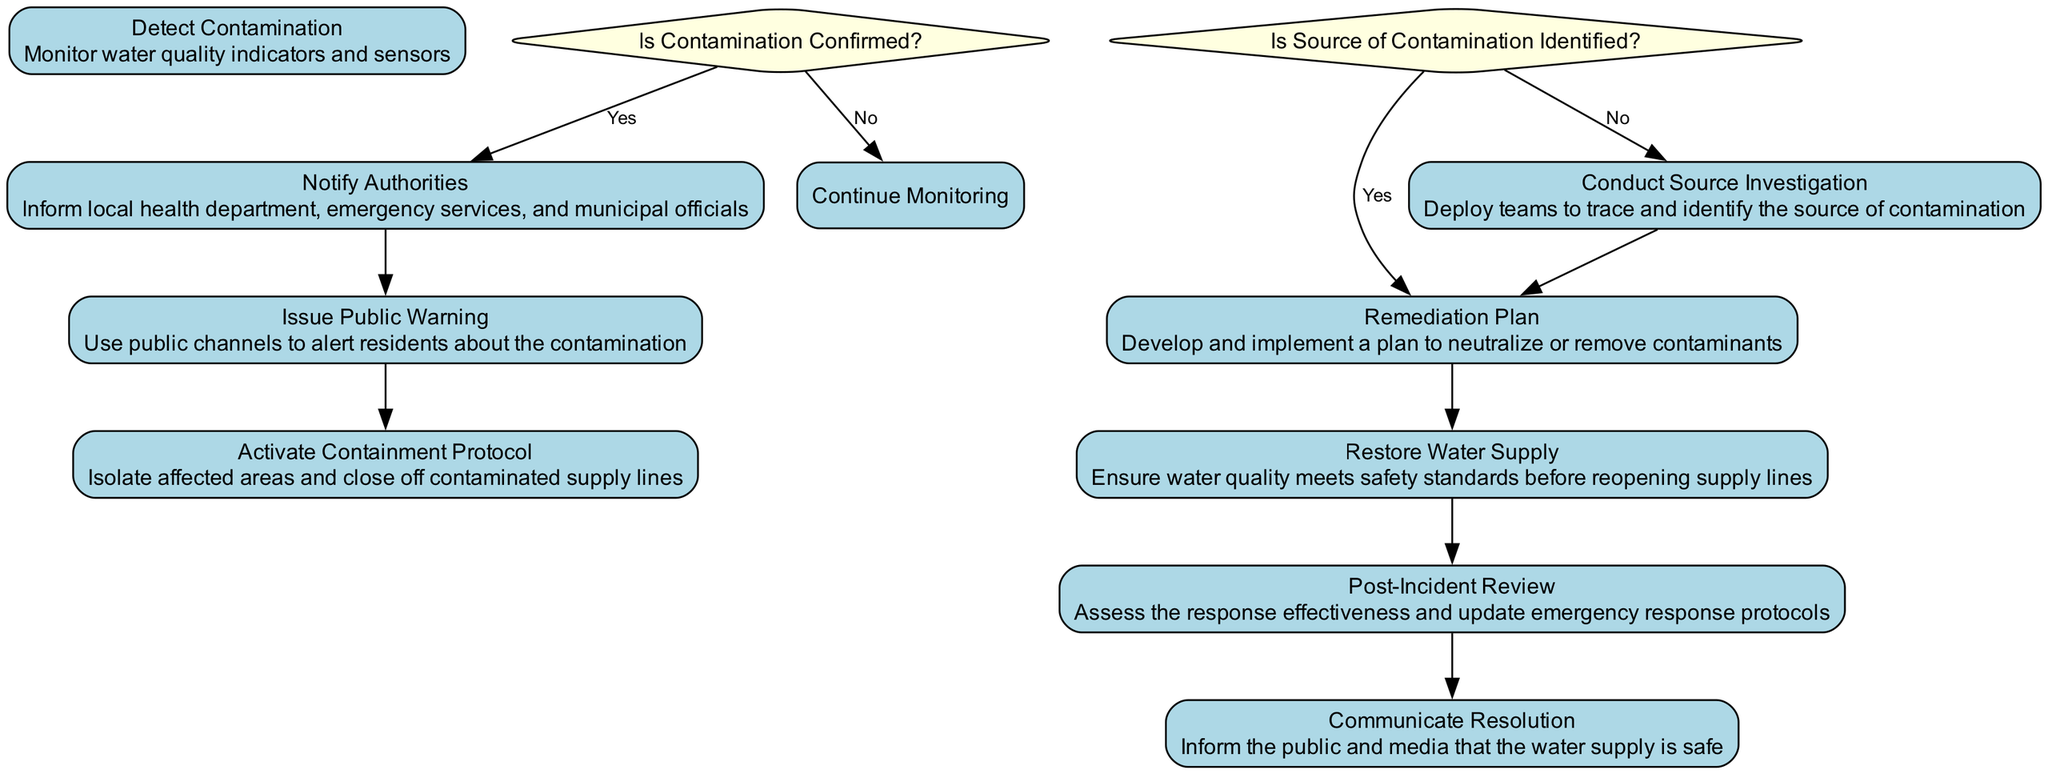What's the first activity in the diagram? The first activity listed in the diagram is "Detect Contamination", which initiates the emergency response process.
Answer: Detect Contamination What is the last activity before the public is informed? The last activity before communicating the resolution to the public is "Restore Water Supply", which ensures that the water quality is safe to resume supply.
Answer: Restore Water Supply How many decision points are present in the diagram? There are two decision points, which are "Is Contamination Confirmed?" and "Is Source of Contamination Identified?".
Answer: 2 If contamination is confirmed, what is the next step? If contamination is confirmed, the next step is to "Notify Authorities" to ensure all relevant parties are informed to take action.
Answer: Notify Authorities What action follows after "Conduct Source Investigation"? After "Conduct Source Investigation", the next action is "Remediation Plan", which is developed if the source of contamination is identified.
Answer: Remediation Plan What type of diagram is this? This is an Activity Diagram, which lays out the sequence of actions and decisions during an emergency response plan.
Answer: Activity Diagram What happens if contamination is not confirmed? If contamination is not confirmed, the process will lead back to "Continue Monitoring" to keep assessing water quality indicators.
Answer: Continue Monitoring What is the primary purpose of the "Post-Incident Review"? The primary purpose of the "Post-Incident Review" is to assess the effectiveness of the emergency response and update the procedures for future incidents.
Answer: Assess effectiveness Which activity comes immediately after "Issue Public Warning"? The activity that comes immediately after "Issue Public Warning" is "Activate Containment Protocol", which involves isolating the affected areas.
Answer: Activate Containment Protocol 